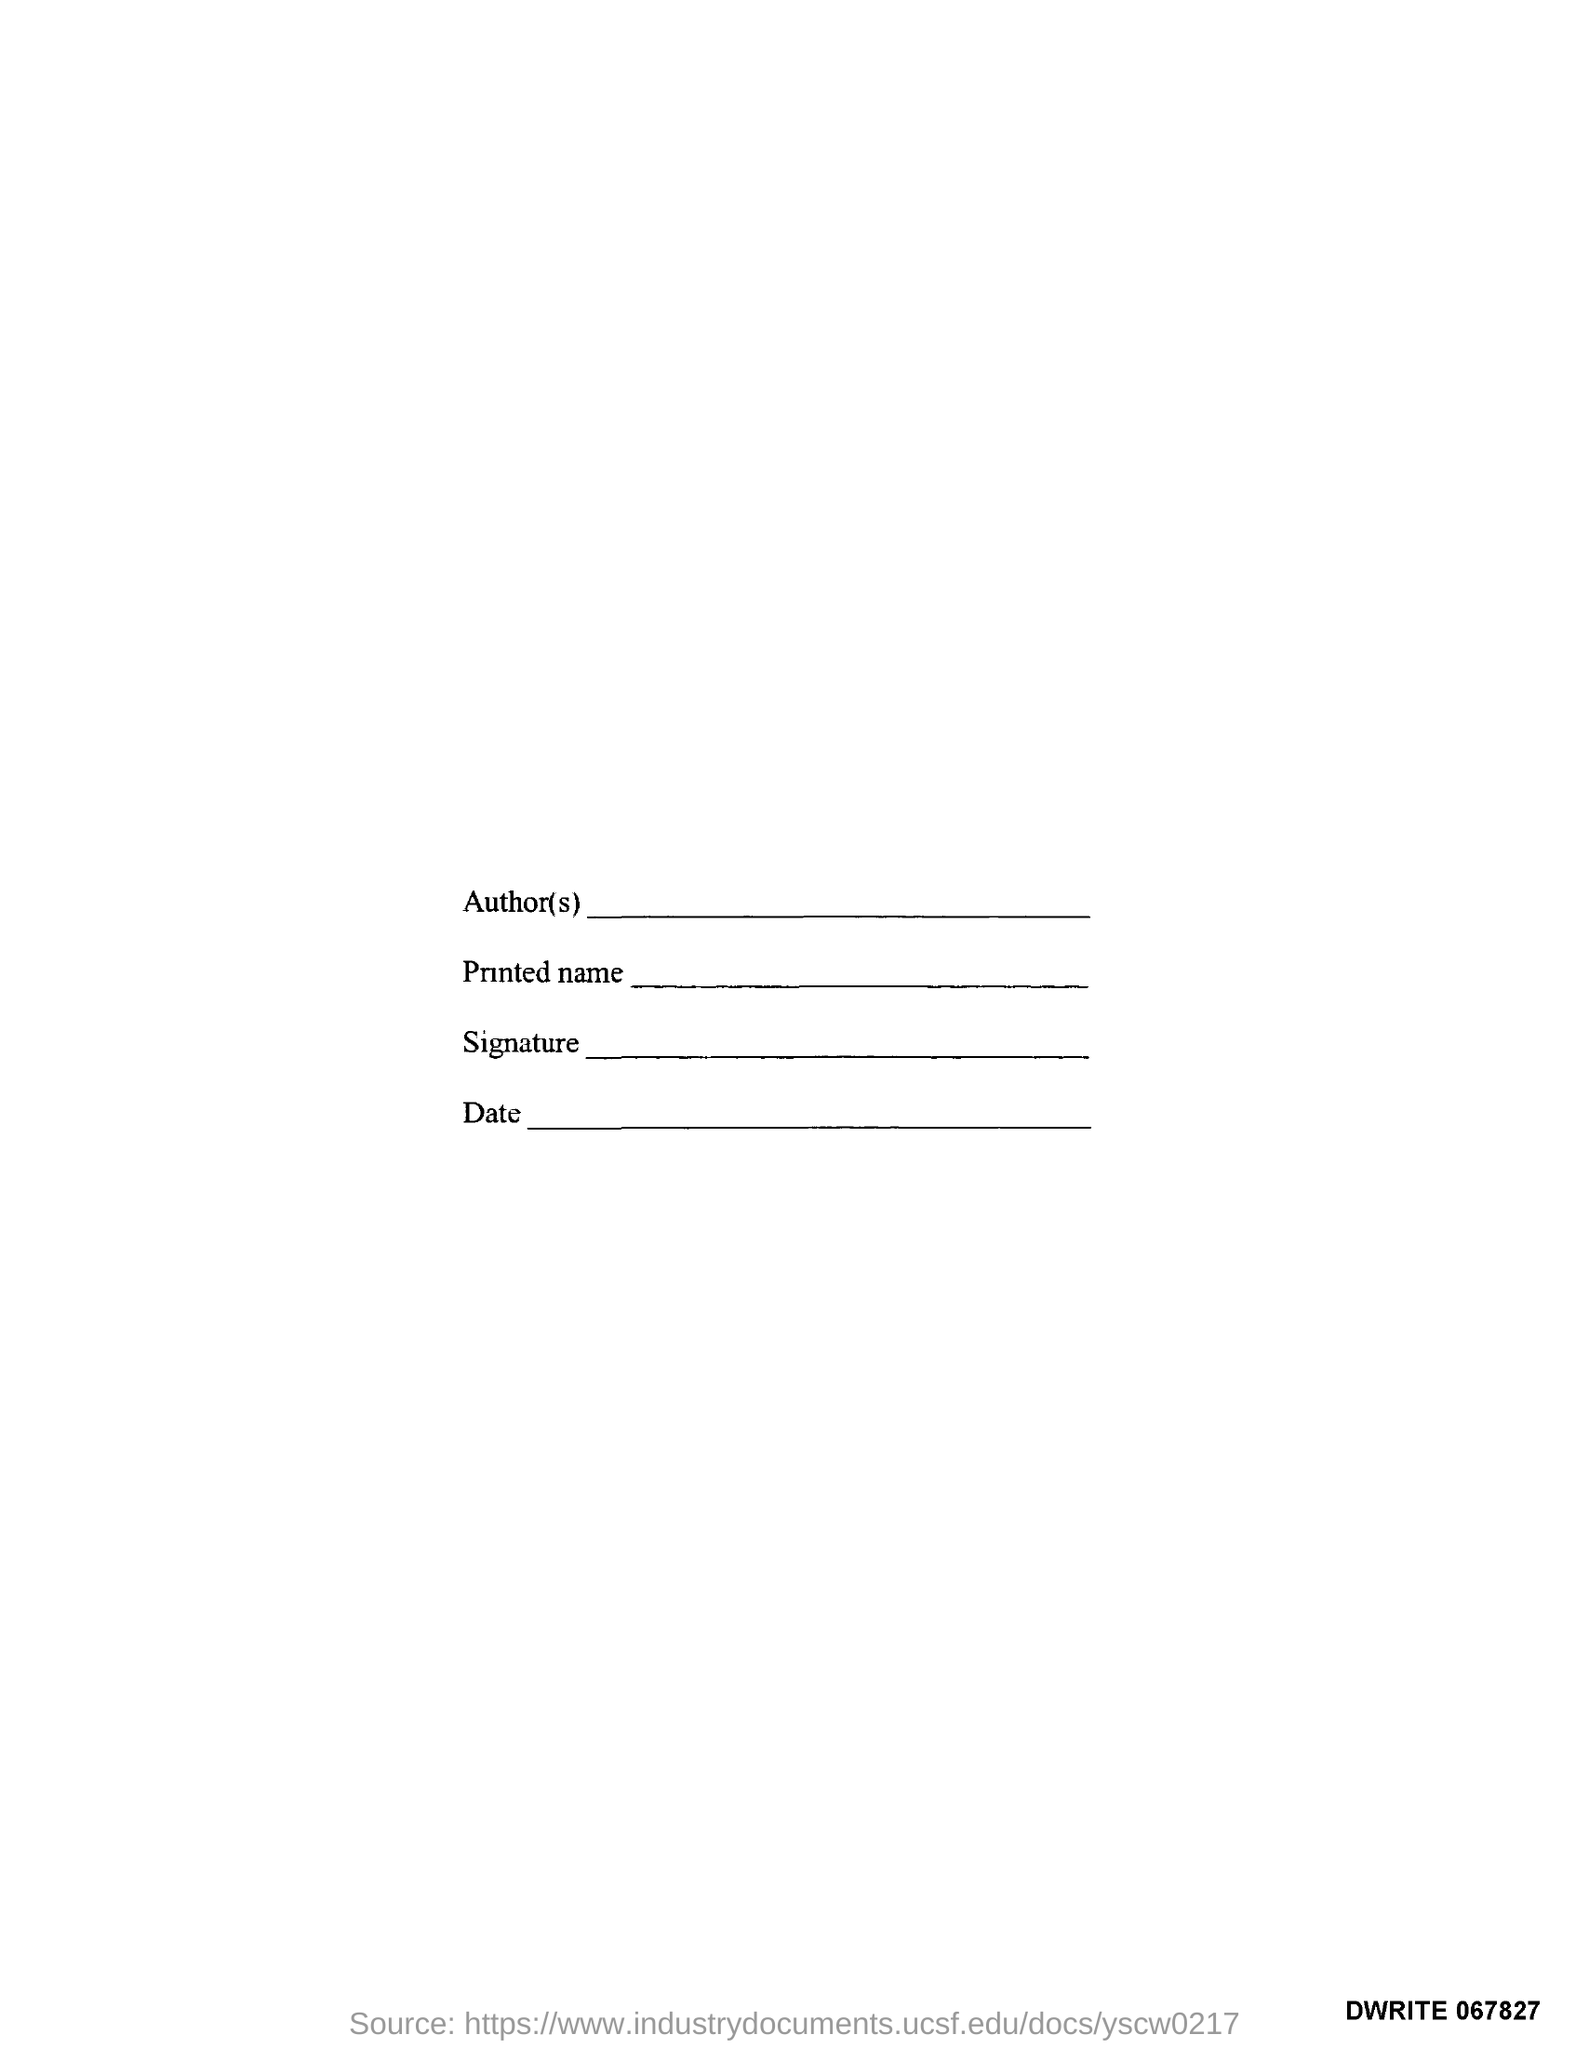What is the first text in the document?
Your response must be concise. Author(s). What is the third text in the document?
Your response must be concise. Signature. What is the fourth text in the document?
Your answer should be very brief. Date. 